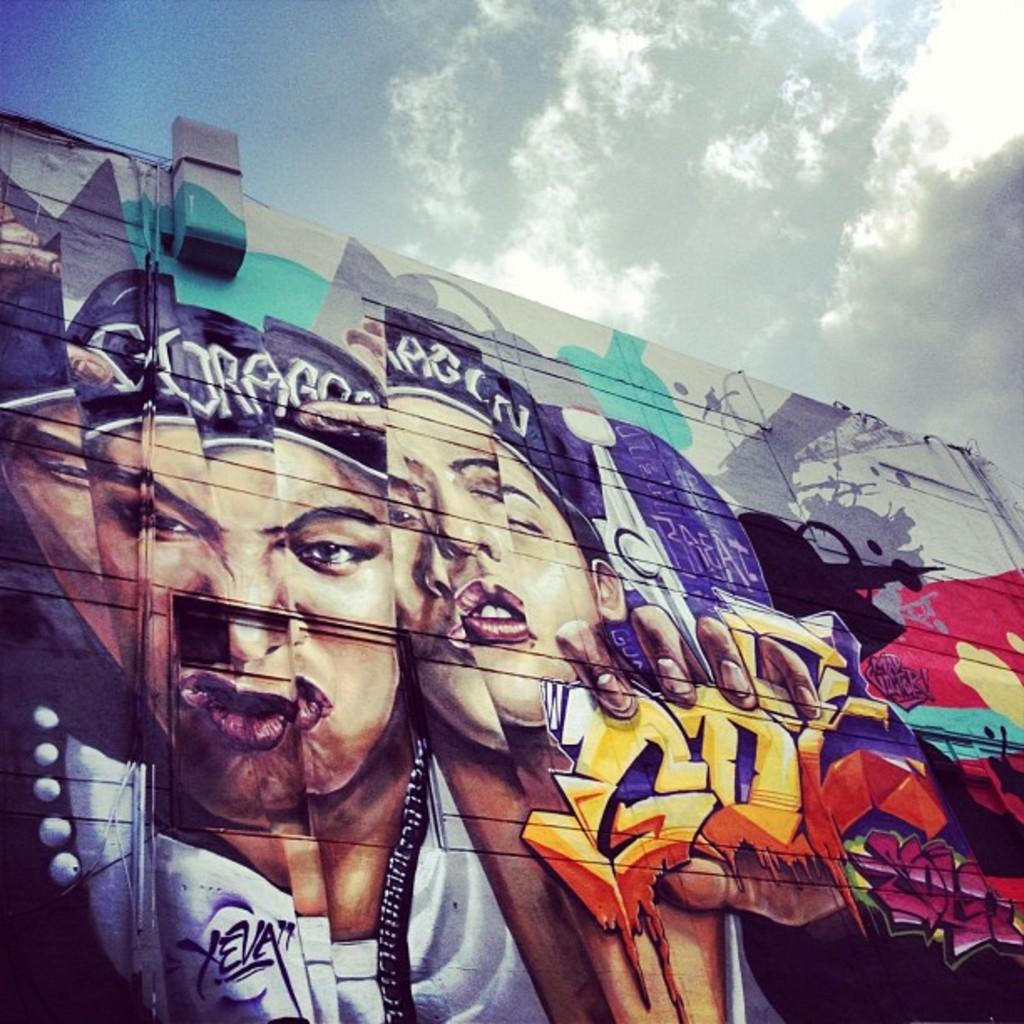What is depicted on the wall in the image? There is graffiti on a wall in the image. What can be seen in the sky in the image? There are clouds visible in the sky in the image. How does the graffiti change into a different image in the image? The graffiti does not change into a different image in the image; it remains the same. What type of magic is being performed by the clouds in the image? There is no magic being performed by the clouds in the image; they are simply clouds in the sky. 